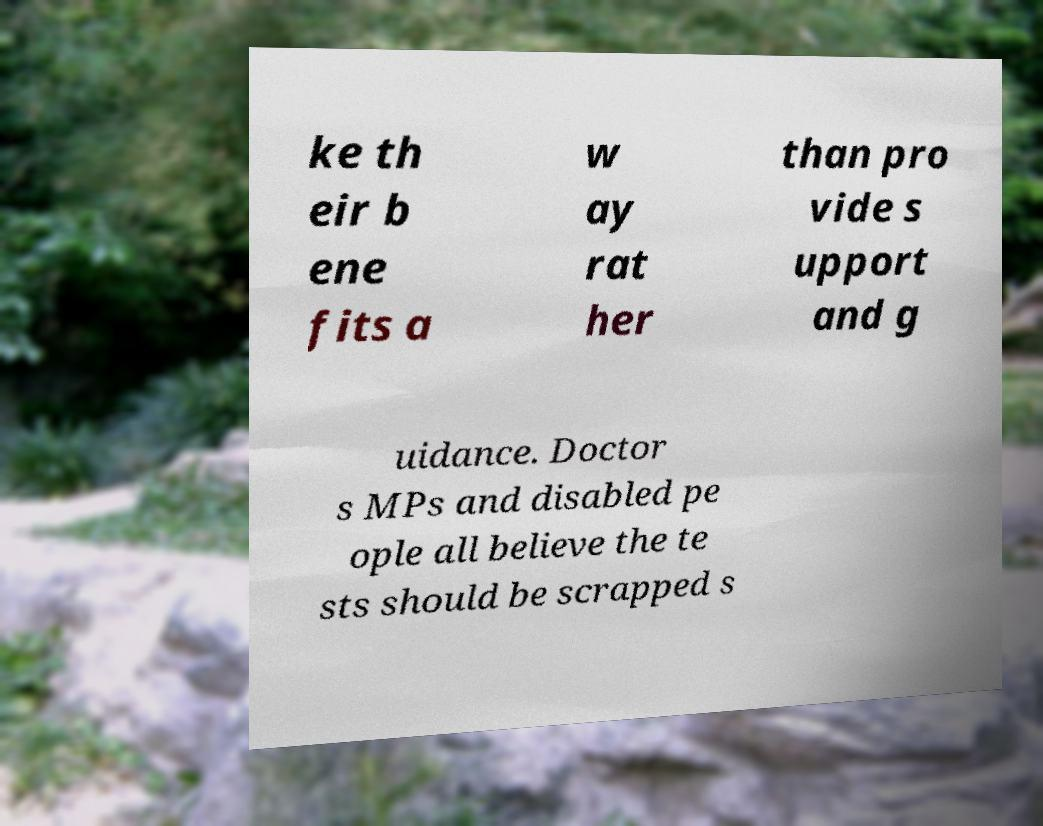Please identify and transcribe the text found in this image. ke th eir b ene fits a w ay rat her than pro vide s upport and g uidance. Doctor s MPs and disabled pe ople all believe the te sts should be scrapped s 